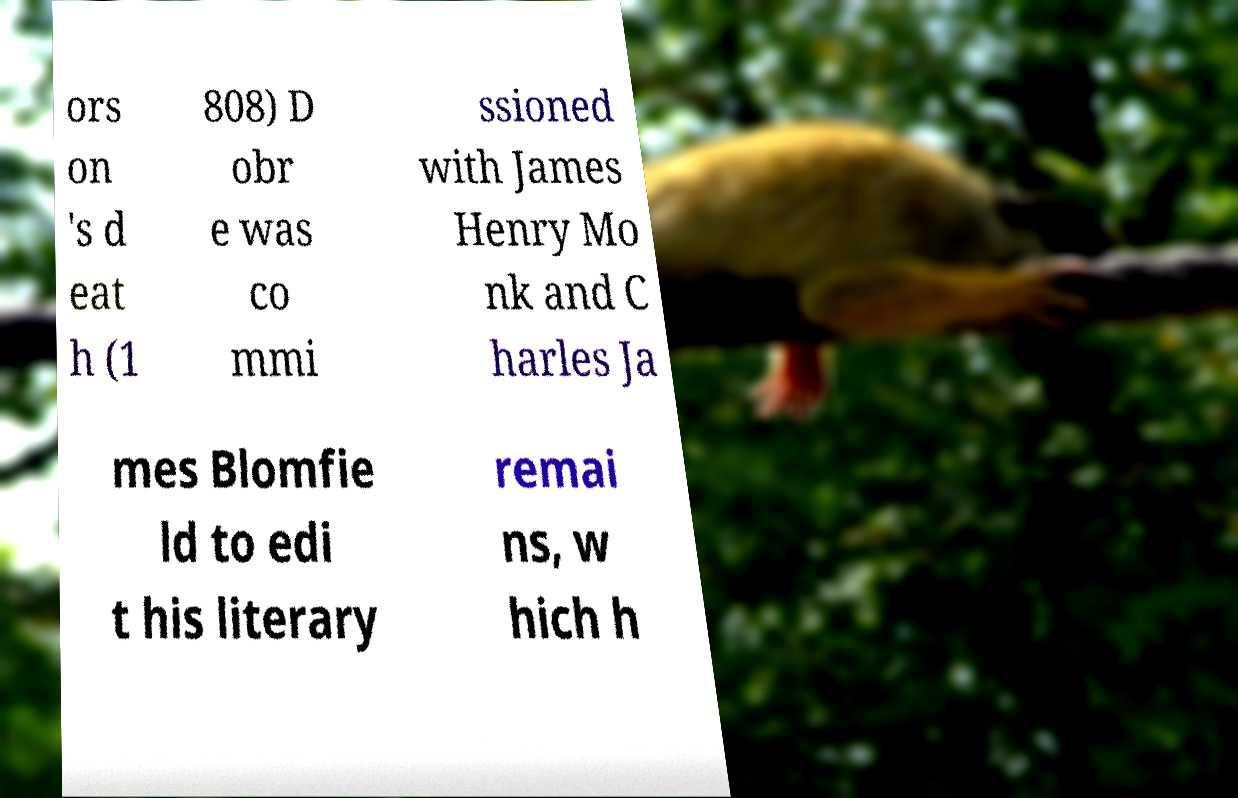There's text embedded in this image that I need extracted. Can you transcribe it verbatim? ors on 's d eat h (1 808) D obr e was co mmi ssioned with James Henry Mo nk and C harles Ja mes Blomfie ld to edi t his literary remai ns, w hich h 